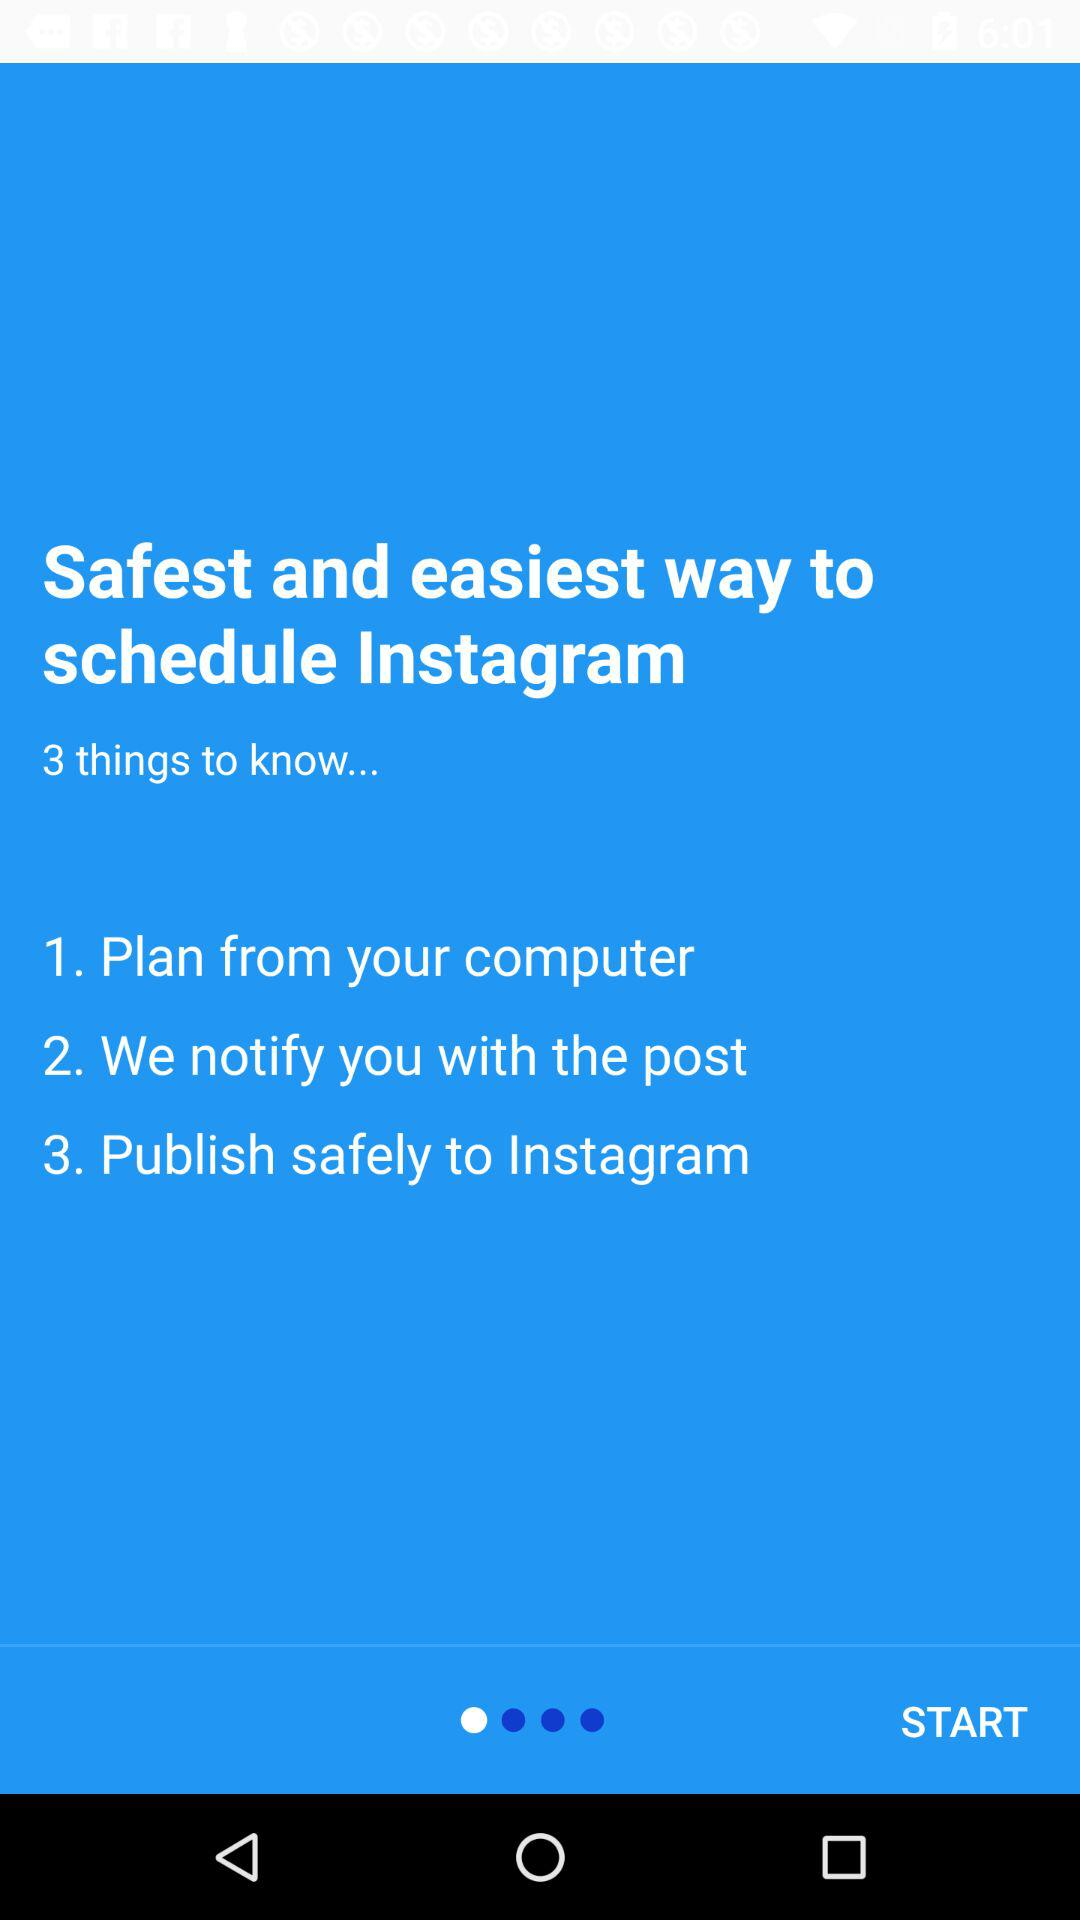How many steps are there in the process of scheduling an Instagram post?
Answer the question using a single word or phrase. 3 